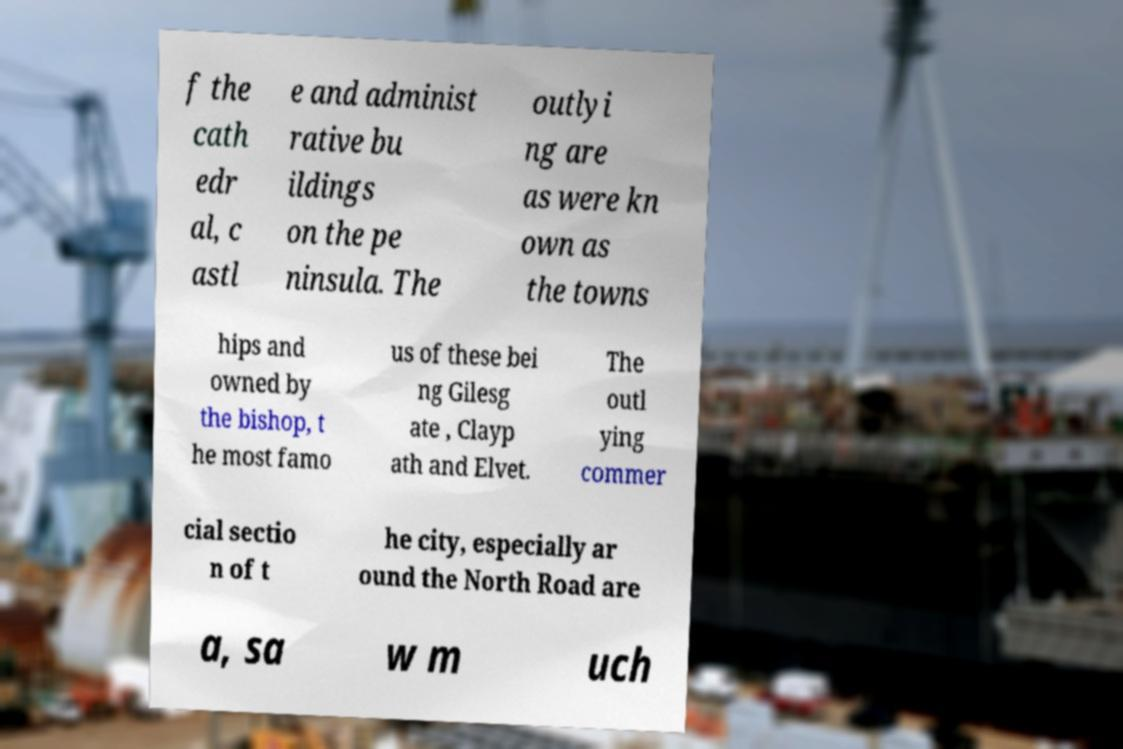Please read and relay the text visible in this image. What does it say? f the cath edr al, c astl e and administ rative bu ildings on the pe ninsula. The outlyi ng are as were kn own as the towns hips and owned by the bishop, t he most famo us of these bei ng Gilesg ate , Clayp ath and Elvet. The outl ying commer cial sectio n of t he city, especially ar ound the North Road are a, sa w m uch 